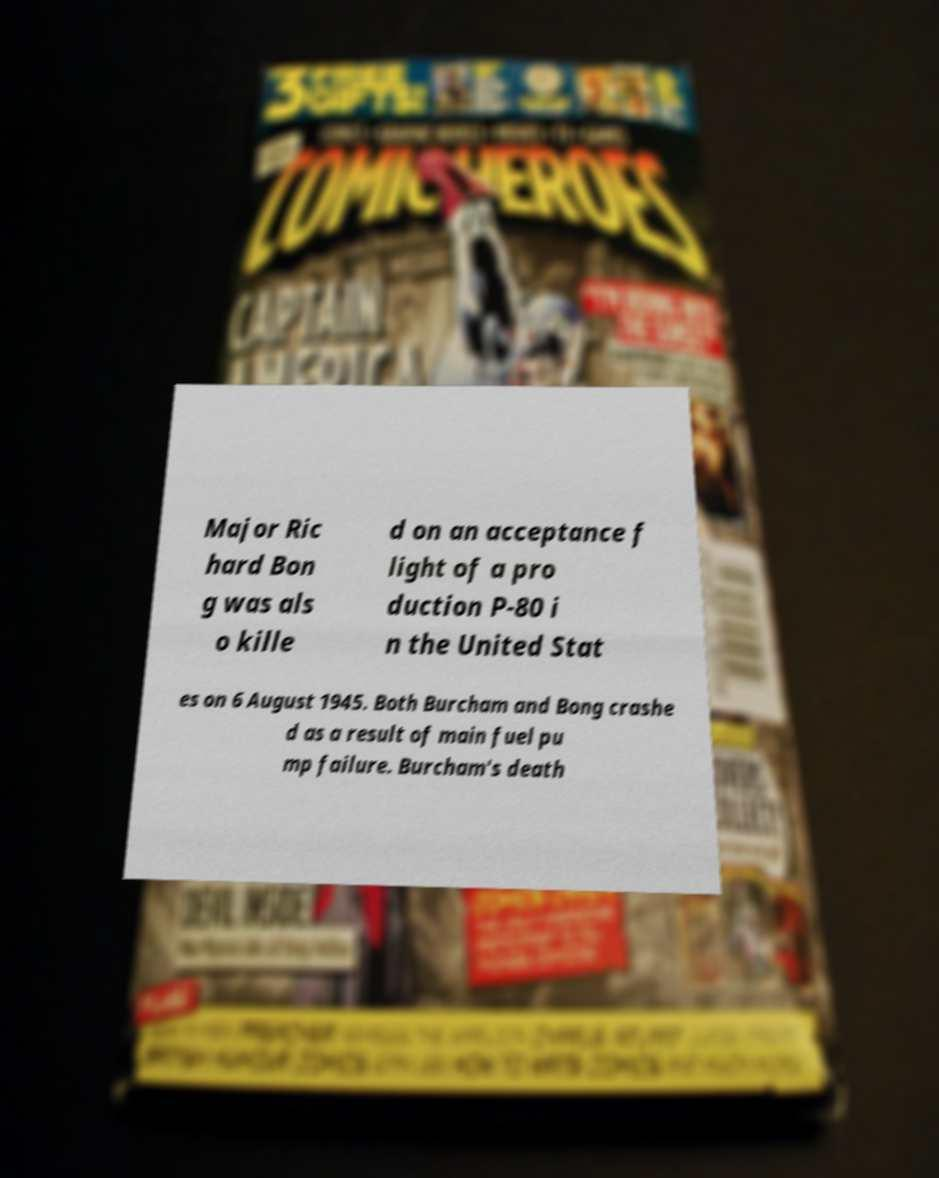Please read and relay the text visible in this image. What does it say? Major Ric hard Bon g was als o kille d on an acceptance f light of a pro duction P-80 i n the United Stat es on 6 August 1945. Both Burcham and Bong crashe d as a result of main fuel pu mp failure. Burcham's death 